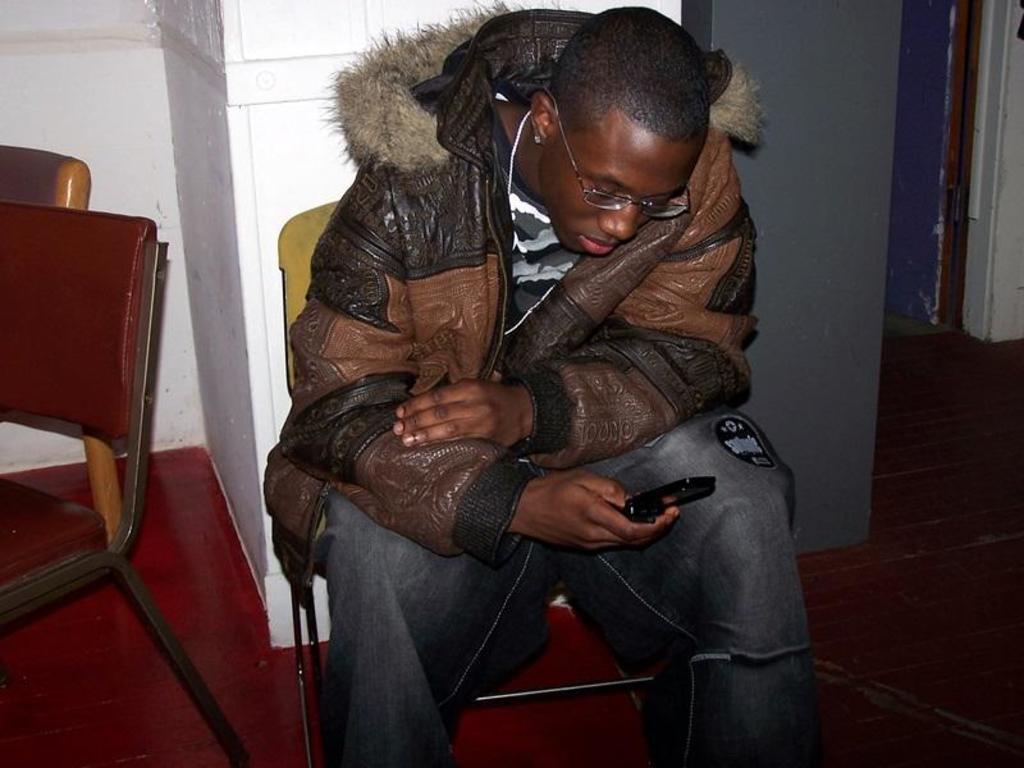In one or two sentences, can you explain what this image depicts? In this image we can see a person sitting on the chair and holding a mobile phone in one of his hands. In the background we can see walls and chairs. 